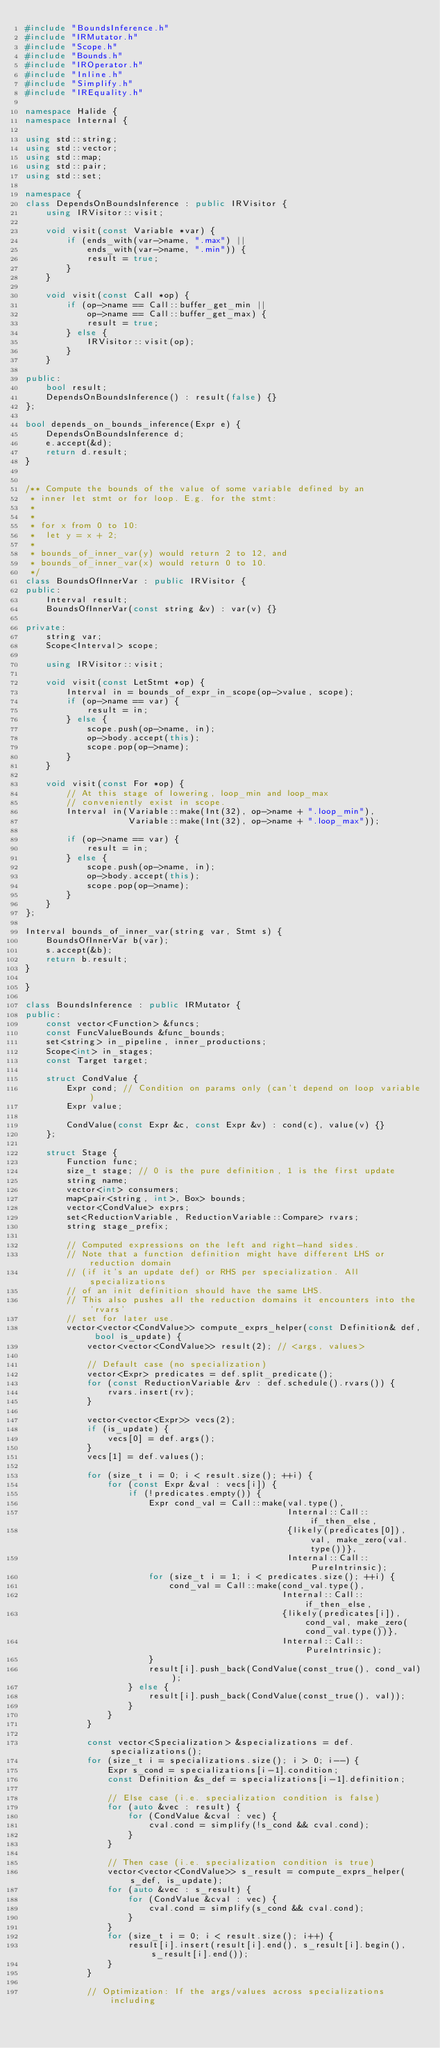<code> <loc_0><loc_0><loc_500><loc_500><_C++_>#include "BoundsInference.h"
#include "IRMutator.h"
#include "Scope.h"
#include "Bounds.h"
#include "IROperator.h"
#include "Inline.h"
#include "Simplify.h"
#include "IREquality.h"

namespace Halide {
namespace Internal {

using std::string;
using std::vector;
using std::map;
using std::pair;
using std::set;

namespace {
class DependsOnBoundsInference : public IRVisitor {
    using IRVisitor::visit;

    void visit(const Variable *var) {
        if (ends_with(var->name, ".max") ||
            ends_with(var->name, ".min")) {
            result = true;
        }
    }

    void visit(const Call *op) {
        if (op->name == Call::buffer_get_min ||
            op->name == Call::buffer_get_max) {
            result = true;
        } else {
            IRVisitor::visit(op);
        }
    }

public:
    bool result;
    DependsOnBoundsInference() : result(false) {}
};

bool depends_on_bounds_inference(Expr e) {
    DependsOnBoundsInference d;
    e.accept(&d);
    return d.result;
}


/** Compute the bounds of the value of some variable defined by an
 * inner let stmt or for loop. E.g. for the stmt:
 *
 *
 * for x from 0 to 10:
 *  let y = x + 2;
 *
 * bounds_of_inner_var(y) would return 2 to 12, and
 * bounds_of_inner_var(x) would return 0 to 10.
 */
class BoundsOfInnerVar : public IRVisitor {
public:
    Interval result;
    BoundsOfInnerVar(const string &v) : var(v) {}

private:
    string var;
    Scope<Interval> scope;

    using IRVisitor::visit;

    void visit(const LetStmt *op) {
        Interval in = bounds_of_expr_in_scope(op->value, scope);
        if (op->name == var) {
            result = in;
        } else {
            scope.push(op->name, in);
            op->body.accept(this);
            scope.pop(op->name);
        }
    }

    void visit(const For *op) {
        // At this stage of lowering, loop_min and loop_max
        // conveniently exist in scope.
        Interval in(Variable::make(Int(32), op->name + ".loop_min"),
                    Variable::make(Int(32), op->name + ".loop_max"));

        if (op->name == var) {
            result = in;
        } else {
            scope.push(op->name, in);
            op->body.accept(this);
            scope.pop(op->name);
        }
    }
};

Interval bounds_of_inner_var(string var, Stmt s) {
    BoundsOfInnerVar b(var);
    s.accept(&b);
    return b.result;
}

}

class BoundsInference : public IRMutator {
public:
    const vector<Function> &funcs;
    const FuncValueBounds &func_bounds;
    set<string> in_pipeline, inner_productions;
    Scope<int> in_stages;
    const Target target;

    struct CondValue {
        Expr cond; // Condition on params only (can't depend on loop variable)
        Expr value;

        CondValue(const Expr &c, const Expr &v) : cond(c), value(v) {}
    };

    struct Stage {
        Function func;
        size_t stage; // 0 is the pure definition, 1 is the first update
        string name;
        vector<int> consumers;
        map<pair<string, int>, Box> bounds;
        vector<CondValue> exprs;
        set<ReductionVariable, ReductionVariable::Compare> rvars;
        string stage_prefix;

        // Computed expressions on the left and right-hand sides.
        // Note that a function definition might have different LHS or reduction domain
        // (if it's an update def) or RHS per specialization. All specializations
        // of an init definition should have the same LHS.
        // This also pushes all the reduction domains it encounters into the 'rvars'
        // set for later use.
        vector<vector<CondValue>> compute_exprs_helper(const Definition& def, bool is_update) {
            vector<vector<CondValue>> result(2); // <args, values>

            // Default case (no specialization)
            vector<Expr> predicates = def.split_predicate();
            for (const ReductionVariable &rv : def.schedule().rvars()) {
                rvars.insert(rv);
            }

            vector<vector<Expr>> vecs(2);
            if (is_update) {
                vecs[0] = def.args();
            }
            vecs[1] = def.values();

            for (size_t i = 0; i < result.size(); ++i) {
                for (const Expr &val : vecs[i]) {
                    if (!predicates.empty()) {
                        Expr cond_val = Call::make(val.type(),
                                                   Internal::Call::if_then_else,
                                                   {likely(predicates[0]), val, make_zero(val.type())},
                                                   Internal::Call::PureIntrinsic);
                        for (size_t i = 1; i < predicates.size(); ++i) {
                            cond_val = Call::make(cond_val.type(),
                                                  Internal::Call::if_then_else,
                                                  {likely(predicates[i]), cond_val, make_zero(cond_val.type())},
                                                  Internal::Call::PureIntrinsic);
                        }
                        result[i].push_back(CondValue(const_true(), cond_val));
                    } else {
                        result[i].push_back(CondValue(const_true(), val));
                    }
                }
            }

            const vector<Specialization> &specializations = def.specializations();
            for (size_t i = specializations.size(); i > 0; i--) {
                Expr s_cond = specializations[i-1].condition;
                const Definition &s_def = specializations[i-1].definition;

                // Else case (i.e. specialization condition is false)
                for (auto &vec : result) {
                    for (CondValue &cval : vec) {
                        cval.cond = simplify(!s_cond && cval.cond);
                    }
                }

                // Then case (i.e. specialization condition is true)
                vector<vector<CondValue>> s_result = compute_exprs_helper(s_def, is_update);
                for (auto &vec : s_result) {
                    for (CondValue &cval : vec) {
                        cval.cond = simplify(s_cond && cval.cond);
                    }
                }
                for (size_t i = 0; i < result.size(); i++) {
                    result[i].insert(result[i].end(), s_result[i].begin(), s_result[i].end());
                }
            }

            // Optimization: If the args/values across specializations including</code> 